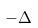Convert formula to latex. <formula><loc_0><loc_0><loc_500><loc_500>- \Delta</formula> 